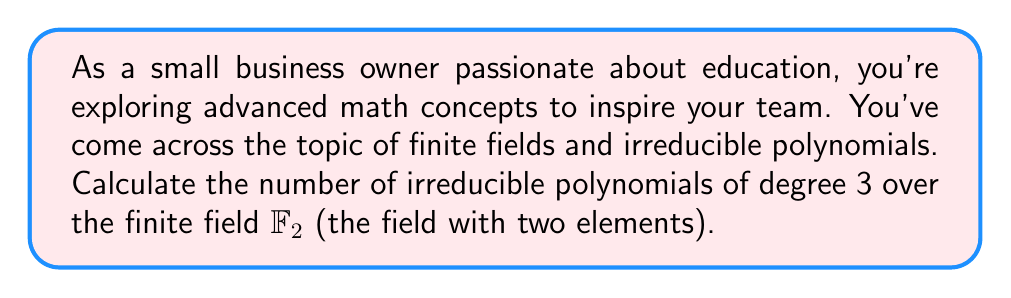Give your solution to this math problem. Let's approach this step-by-step:

1) First, recall that the number of irreducible polynomials of degree $n$ over a finite field $\mathbb{F}_q$ is given by the formula:

   $$N_n = \frac{1}{n} \sum_{d|n} \mu(d)q^{n/d}$$

   where $\mu(d)$ is the Möbius function.

2) In our case, $n = 3$ and $q = 2$ (since we're working over $\mathbb{F}_2$).

3) The divisors of 3 are 1 and 3. So our sum will have two terms:

   $$N_3 = \frac{1}{3} (\mu(1)2^{3/1} + \mu(3)2^{3/3})$$

4) Now, let's calculate the Möbius function values:
   - $\mu(1) = 1$
   - $\mu(3) = -1$ (since 3 is prime)

5) Substituting these values:

   $$N_3 = \frac{1}{3} (1 \cdot 2^3 + (-1) \cdot 2^1)$$

6) Simplify:

   $$N_3 = \frac{1}{3} (8 - 2) = \frac{1}{3} (6) = 2$$

Therefore, there are 2 irreducible polynomials of degree 3 over $\mathbb{F}_2$.
Answer: 2 